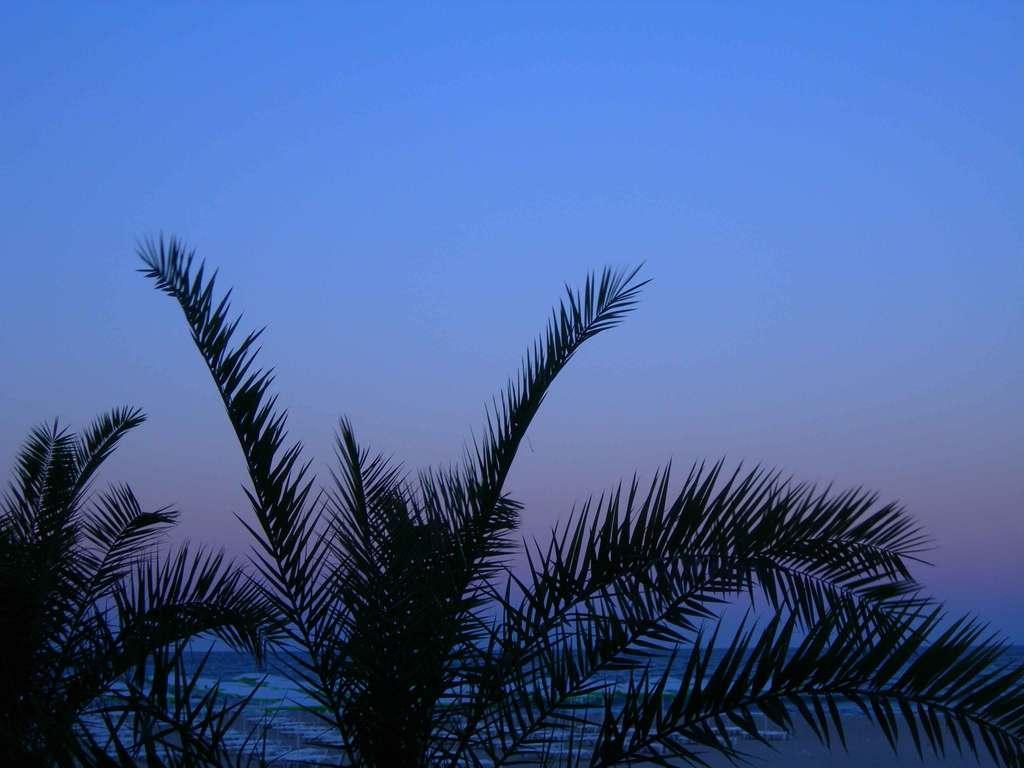Could you give a brief overview of what you see in this image? In this image there are trees, in the background of the image there is water. 